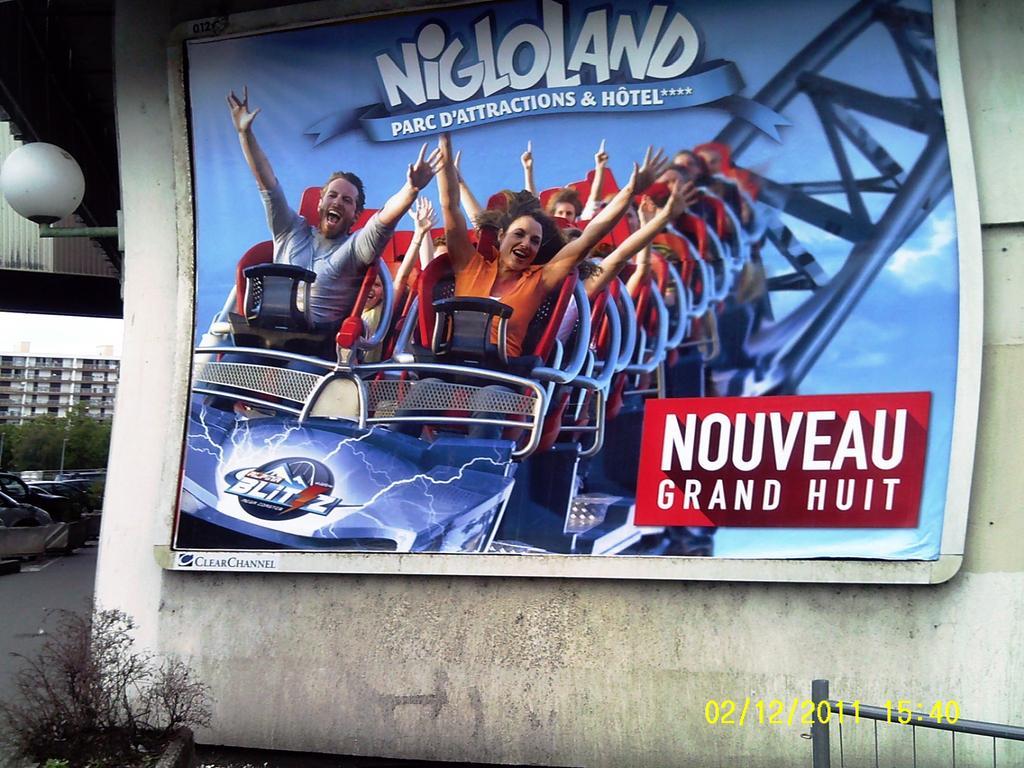How would you summarize this image in a sentence or two? In this picture we can see a poster on the wall, in the background we can find a light, few vehicles, trees and buildings, at the right bottom of the image we can see few metal rods and timestamp. 